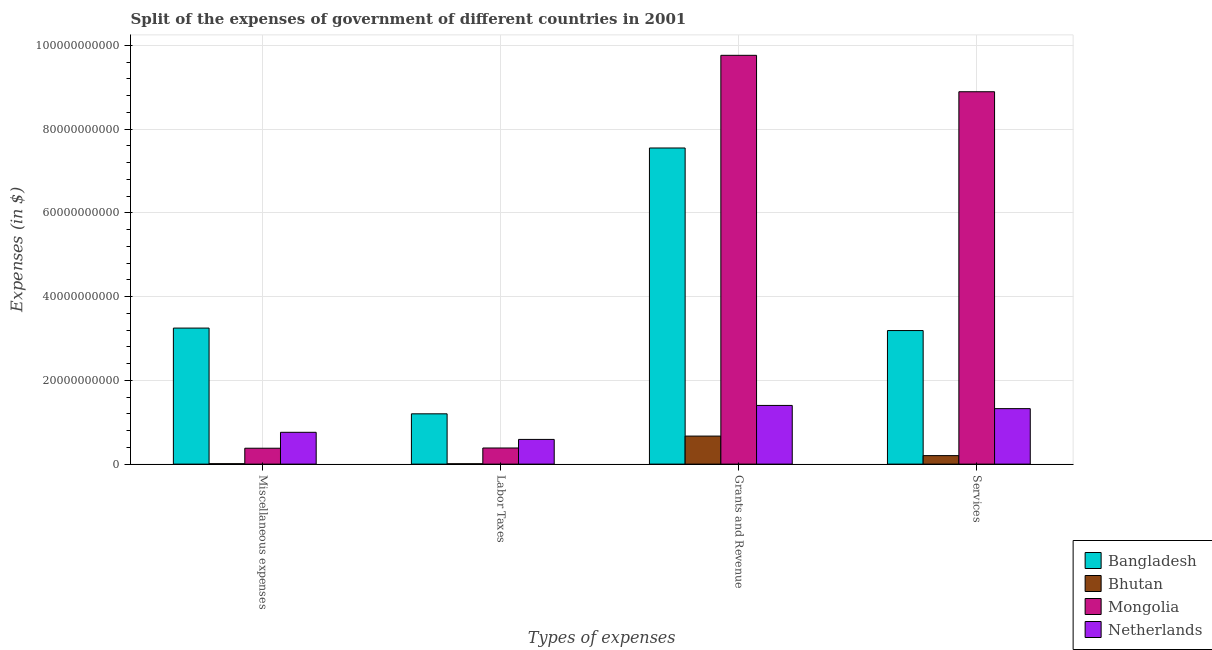Are the number of bars on each tick of the X-axis equal?
Offer a terse response. Yes. How many bars are there on the 4th tick from the left?
Offer a terse response. 4. How many bars are there on the 1st tick from the right?
Ensure brevity in your answer.  4. What is the label of the 4th group of bars from the left?
Provide a short and direct response. Services. What is the amount spent on miscellaneous expenses in Netherlands?
Provide a short and direct response. 7.60e+09. Across all countries, what is the maximum amount spent on services?
Your answer should be compact. 8.89e+1. Across all countries, what is the minimum amount spent on services?
Make the answer very short. 2.03e+09. In which country was the amount spent on services minimum?
Provide a succinct answer. Bhutan. What is the total amount spent on labor taxes in the graph?
Your answer should be compact. 2.18e+1. What is the difference between the amount spent on services in Netherlands and that in Mongolia?
Give a very brief answer. -7.57e+1. What is the difference between the amount spent on services in Netherlands and the amount spent on miscellaneous expenses in Mongolia?
Provide a succinct answer. 9.46e+09. What is the average amount spent on miscellaneous expenses per country?
Provide a succinct answer. 1.10e+1. What is the difference between the amount spent on labor taxes and amount spent on miscellaneous expenses in Mongolia?
Your response must be concise. 5.40e+07. In how many countries, is the amount spent on labor taxes greater than 48000000000 $?
Offer a terse response. 0. What is the ratio of the amount spent on labor taxes in Netherlands to that in Mongolia?
Keep it short and to the point. 1.53. Is the amount spent on miscellaneous expenses in Bangladesh less than that in Netherlands?
Make the answer very short. No. What is the difference between the highest and the second highest amount spent on labor taxes?
Ensure brevity in your answer.  6.11e+09. What is the difference between the highest and the lowest amount spent on grants and revenue?
Your answer should be compact. 9.09e+1. In how many countries, is the amount spent on miscellaneous expenses greater than the average amount spent on miscellaneous expenses taken over all countries?
Offer a very short reply. 1. What does the 3rd bar from the right in Grants and Revenue represents?
Your answer should be compact. Bhutan. Is it the case that in every country, the sum of the amount spent on miscellaneous expenses and amount spent on labor taxes is greater than the amount spent on grants and revenue?
Provide a succinct answer. No. How many countries are there in the graph?
Provide a succinct answer. 4. What is the difference between two consecutive major ticks on the Y-axis?
Provide a short and direct response. 2.00e+1. Where does the legend appear in the graph?
Offer a very short reply. Bottom right. What is the title of the graph?
Your answer should be very brief. Split of the expenses of government of different countries in 2001. What is the label or title of the X-axis?
Provide a succinct answer. Types of expenses. What is the label or title of the Y-axis?
Keep it short and to the point. Expenses (in $). What is the Expenses (in $) of Bangladesh in Miscellaneous expenses?
Give a very brief answer. 3.25e+1. What is the Expenses (in $) in Bhutan in Miscellaneous expenses?
Provide a short and direct response. 1.02e+08. What is the Expenses (in $) of Mongolia in Miscellaneous expenses?
Offer a very short reply. 3.80e+09. What is the Expenses (in $) in Netherlands in Miscellaneous expenses?
Give a very brief answer. 7.60e+09. What is the Expenses (in $) of Bangladesh in Labor Taxes?
Give a very brief answer. 1.20e+1. What is the Expenses (in $) of Bhutan in Labor Taxes?
Provide a succinct answer. 8.44e+07. What is the Expenses (in $) in Mongolia in Labor Taxes?
Offer a terse response. 3.85e+09. What is the Expenses (in $) in Netherlands in Labor Taxes?
Give a very brief answer. 5.90e+09. What is the Expenses (in $) of Bangladesh in Grants and Revenue?
Provide a short and direct response. 7.55e+1. What is the Expenses (in $) in Bhutan in Grants and Revenue?
Make the answer very short. 6.69e+09. What is the Expenses (in $) of Mongolia in Grants and Revenue?
Offer a terse response. 9.76e+1. What is the Expenses (in $) in Netherlands in Grants and Revenue?
Your answer should be compact. 1.40e+1. What is the Expenses (in $) in Bangladesh in Services?
Ensure brevity in your answer.  3.19e+1. What is the Expenses (in $) of Bhutan in Services?
Offer a very short reply. 2.03e+09. What is the Expenses (in $) of Mongolia in Services?
Your response must be concise. 8.89e+1. What is the Expenses (in $) of Netherlands in Services?
Keep it short and to the point. 1.33e+1. Across all Types of expenses, what is the maximum Expenses (in $) of Bangladesh?
Provide a succinct answer. 7.55e+1. Across all Types of expenses, what is the maximum Expenses (in $) of Bhutan?
Your response must be concise. 6.69e+09. Across all Types of expenses, what is the maximum Expenses (in $) of Mongolia?
Keep it short and to the point. 9.76e+1. Across all Types of expenses, what is the maximum Expenses (in $) of Netherlands?
Your response must be concise. 1.40e+1. Across all Types of expenses, what is the minimum Expenses (in $) of Bangladesh?
Your answer should be compact. 1.20e+1. Across all Types of expenses, what is the minimum Expenses (in $) in Bhutan?
Keep it short and to the point. 8.44e+07. Across all Types of expenses, what is the minimum Expenses (in $) in Mongolia?
Give a very brief answer. 3.80e+09. Across all Types of expenses, what is the minimum Expenses (in $) of Netherlands?
Offer a terse response. 5.90e+09. What is the total Expenses (in $) of Bangladesh in the graph?
Your response must be concise. 1.52e+11. What is the total Expenses (in $) of Bhutan in the graph?
Offer a very short reply. 8.91e+09. What is the total Expenses (in $) in Mongolia in the graph?
Offer a terse response. 1.94e+11. What is the total Expenses (in $) in Netherlands in the graph?
Offer a terse response. 4.08e+1. What is the difference between the Expenses (in $) of Bangladesh in Miscellaneous expenses and that in Labor Taxes?
Your response must be concise. 2.05e+1. What is the difference between the Expenses (in $) of Bhutan in Miscellaneous expenses and that in Labor Taxes?
Ensure brevity in your answer.  1.74e+07. What is the difference between the Expenses (in $) in Mongolia in Miscellaneous expenses and that in Labor Taxes?
Ensure brevity in your answer.  -5.40e+07. What is the difference between the Expenses (in $) in Netherlands in Miscellaneous expenses and that in Labor Taxes?
Offer a very short reply. 1.70e+09. What is the difference between the Expenses (in $) in Bangladesh in Miscellaneous expenses and that in Grants and Revenue?
Offer a very short reply. -4.30e+1. What is the difference between the Expenses (in $) in Bhutan in Miscellaneous expenses and that in Grants and Revenue?
Offer a terse response. -6.59e+09. What is the difference between the Expenses (in $) in Mongolia in Miscellaneous expenses and that in Grants and Revenue?
Keep it short and to the point. -9.38e+1. What is the difference between the Expenses (in $) in Netherlands in Miscellaneous expenses and that in Grants and Revenue?
Your response must be concise. -6.42e+09. What is the difference between the Expenses (in $) in Bangladesh in Miscellaneous expenses and that in Services?
Give a very brief answer. 5.89e+08. What is the difference between the Expenses (in $) in Bhutan in Miscellaneous expenses and that in Services?
Ensure brevity in your answer.  -1.93e+09. What is the difference between the Expenses (in $) in Mongolia in Miscellaneous expenses and that in Services?
Offer a very short reply. -8.51e+1. What is the difference between the Expenses (in $) in Netherlands in Miscellaneous expenses and that in Services?
Keep it short and to the point. -5.65e+09. What is the difference between the Expenses (in $) of Bangladesh in Labor Taxes and that in Grants and Revenue?
Your answer should be compact. -6.35e+1. What is the difference between the Expenses (in $) of Bhutan in Labor Taxes and that in Grants and Revenue?
Your answer should be very brief. -6.61e+09. What is the difference between the Expenses (in $) in Mongolia in Labor Taxes and that in Grants and Revenue?
Make the answer very short. -9.38e+1. What is the difference between the Expenses (in $) in Netherlands in Labor Taxes and that in Grants and Revenue?
Offer a terse response. -8.12e+09. What is the difference between the Expenses (in $) of Bangladesh in Labor Taxes and that in Services?
Offer a terse response. -1.99e+1. What is the difference between the Expenses (in $) of Bhutan in Labor Taxes and that in Services?
Make the answer very short. -1.94e+09. What is the difference between the Expenses (in $) of Mongolia in Labor Taxes and that in Services?
Your answer should be compact. -8.51e+1. What is the difference between the Expenses (in $) in Netherlands in Labor Taxes and that in Services?
Keep it short and to the point. -7.35e+09. What is the difference between the Expenses (in $) of Bangladesh in Grants and Revenue and that in Services?
Offer a very short reply. 4.36e+1. What is the difference between the Expenses (in $) in Bhutan in Grants and Revenue and that in Services?
Your answer should be very brief. 4.67e+09. What is the difference between the Expenses (in $) in Mongolia in Grants and Revenue and that in Services?
Provide a succinct answer. 8.70e+09. What is the difference between the Expenses (in $) in Netherlands in Grants and Revenue and that in Services?
Your answer should be very brief. 7.64e+08. What is the difference between the Expenses (in $) of Bangladesh in Miscellaneous expenses and the Expenses (in $) of Bhutan in Labor Taxes?
Your response must be concise. 3.24e+1. What is the difference between the Expenses (in $) of Bangladesh in Miscellaneous expenses and the Expenses (in $) of Mongolia in Labor Taxes?
Ensure brevity in your answer.  2.86e+1. What is the difference between the Expenses (in $) of Bangladesh in Miscellaneous expenses and the Expenses (in $) of Netherlands in Labor Taxes?
Offer a terse response. 2.66e+1. What is the difference between the Expenses (in $) in Bhutan in Miscellaneous expenses and the Expenses (in $) in Mongolia in Labor Taxes?
Offer a terse response. -3.75e+09. What is the difference between the Expenses (in $) of Bhutan in Miscellaneous expenses and the Expenses (in $) of Netherlands in Labor Taxes?
Ensure brevity in your answer.  -5.80e+09. What is the difference between the Expenses (in $) in Mongolia in Miscellaneous expenses and the Expenses (in $) in Netherlands in Labor Taxes?
Your answer should be compact. -2.10e+09. What is the difference between the Expenses (in $) in Bangladesh in Miscellaneous expenses and the Expenses (in $) in Bhutan in Grants and Revenue?
Offer a very short reply. 2.58e+1. What is the difference between the Expenses (in $) of Bangladesh in Miscellaneous expenses and the Expenses (in $) of Mongolia in Grants and Revenue?
Keep it short and to the point. -6.51e+1. What is the difference between the Expenses (in $) in Bangladesh in Miscellaneous expenses and the Expenses (in $) in Netherlands in Grants and Revenue?
Keep it short and to the point. 1.85e+1. What is the difference between the Expenses (in $) in Bhutan in Miscellaneous expenses and the Expenses (in $) in Mongolia in Grants and Revenue?
Your answer should be compact. -9.75e+1. What is the difference between the Expenses (in $) of Bhutan in Miscellaneous expenses and the Expenses (in $) of Netherlands in Grants and Revenue?
Keep it short and to the point. -1.39e+1. What is the difference between the Expenses (in $) in Mongolia in Miscellaneous expenses and the Expenses (in $) in Netherlands in Grants and Revenue?
Ensure brevity in your answer.  -1.02e+1. What is the difference between the Expenses (in $) of Bangladesh in Miscellaneous expenses and the Expenses (in $) of Bhutan in Services?
Provide a short and direct response. 3.05e+1. What is the difference between the Expenses (in $) in Bangladesh in Miscellaneous expenses and the Expenses (in $) in Mongolia in Services?
Your answer should be very brief. -5.64e+1. What is the difference between the Expenses (in $) in Bangladesh in Miscellaneous expenses and the Expenses (in $) in Netherlands in Services?
Provide a short and direct response. 1.92e+1. What is the difference between the Expenses (in $) in Bhutan in Miscellaneous expenses and the Expenses (in $) in Mongolia in Services?
Ensure brevity in your answer.  -8.88e+1. What is the difference between the Expenses (in $) of Bhutan in Miscellaneous expenses and the Expenses (in $) of Netherlands in Services?
Provide a short and direct response. -1.31e+1. What is the difference between the Expenses (in $) in Mongolia in Miscellaneous expenses and the Expenses (in $) in Netherlands in Services?
Ensure brevity in your answer.  -9.46e+09. What is the difference between the Expenses (in $) of Bangladesh in Labor Taxes and the Expenses (in $) of Bhutan in Grants and Revenue?
Give a very brief answer. 5.32e+09. What is the difference between the Expenses (in $) of Bangladesh in Labor Taxes and the Expenses (in $) of Mongolia in Grants and Revenue?
Offer a very short reply. -8.56e+1. What is the difference between the Expenses (in $) of Bangladesh in Labor Taxes and the Expenses (in $) of Netherlands in Grants and Revenue?
Offer a very short reply. -2.00e+09. What is the difference between the Expenses (in $) of Bhutan in Labor Taxes and the Expenses (in $) of Mongolia in Grants and Revenue?
Offer a very short reply. -9.75e+1. What is the difference between the Expenses (in $) in Bhutan in Labor Taxes and the Expenses (in $) in Netherlands in Grants and Revenue?
Keep it short and to the point. -1.39e+1. What is the difference between the Expenses (in $) in Mongolia in Labor Taxes and the Expenses (in $) in Netherlands in Grants and Revenue?
Provide a succinct answer. -1.02e+1. What is the difference between the Expenses (in $) in Bangladesh in Labor Taxes and the Expenses (in $) in Bhutan in Services?
Offer a terse response. 9.98e+09. What is the difference between the Expenses (in $) of Bangladesh in Labor Taxes and the Expenses (in $) of Mongolia in Services?
Offer a terse response. -7.69e+1. What is the difference between the Expenses (in $) in Bangladesh in Labor Taxes and the Expenses (in $) in Netherlands in Services?
Your answer should be very brief. -1.24e+09. What is the difference between the Expenses (in $) in Bhutan in Labor Taxes and the Expenses (in $) in Mongolia in Services?
Make the answer very short. -8.88e+1. What is the difference between the Expenses (in $) of Bhutan in Labor Taxes and the Expenses (in $) of Netherlands in Services?
Provide a succinct answer. -1.32e+1. What is the difference between the Expenses (in $) in Mongolia in Labor Taxes and the Expenses (in $) in Netherlands in Services?
Give a very brief answer. -9.40e+09. What is the difference between the Expenses (in $) of Bangladesh in Grants and Revenue and the Expenses (in $) of Bhutan in Services?
Ensure brevity in your answer.  7.35e+1. What is the difference between the Expenses (in $) of Bangladesh in Grants and Revenue and the Expenses (in $) of Mongolia in Services?
Offer a terse response. -1.34e+1. What is the difference between the Expenses (in $) in Bangladesh in Grants and Revenue and the Expenses (in $) in Netherlands in Services?
Keep it short and to the point. 6.22e+1. What is the difference between the Expenses (in $) of Bhutan in Grants and Revenue and the Expenses (in $) of Mongolia in Services?
Make the answer very short. -8.22e+1. What is the difference between the Expenses (in $) in Bhutan in Grants and Revenue and the Expenses (in $) in Netherlands in Services?
Provide a succinct answer. -6.56e+09. What is the difference between the Expenses (in $) in Mongolia in Grants and Revenue and the Expenses (in $) in Netherlands in Services?
Your response must be concise. 8.44e+1. What is the average Expenses (in $) in Bangladesh per Types of expenses?
Your answer should be compact. 3.80e+1. What is the average Expenses (in $) in Bhutan per Types of expenses?
Ensure brevity in your answer.  2.23e+09. What is the average Expenses (in $) of Mongolia per Types of expenses?
Keep it short and to the point. 4.86e+1. What is the average Expenses (in $) in Netherlands per Types of expenses?
Offer a very short reply. 1.02e+1. What is the difference between the Expenses (in $) in Bangladesh and Expenses (in $) in Bhutan in Miscellaneous expenses?
Your answer should be compact. 3.24e+1. What is the difference between the Expenses (in $) in Bangladesh and Expenses (in $) in Mongolia in Miscellaneous expenses?
Offer a terse response. 2.87e+1. What is the difference between the Expenses (in $) of Bangladesh and Expenses (in $) of Netherlands in Miscellaneous expenses?
Keep it short and to the point. 2.49e+1. What is the difference between the Expenses (in $) of Bhutan and Expenses (in $) of Mongolia in Miscellaneous expenses?
Offer a terse response. -3.69e+09. What is the difference between the Expenses (in $) of Bhutan and Expenses (in $) of Netherlands in Miscellaneous expenses?
Provide a succinct answer. -7.50e+09. What is the difference between the Expenses (in $) in Mongolia and Expenses (in $) in Netherlands in Miscellaneous expenses?
Your response must be concise. -3.80e+09. What is the difference between the Expenses (in $) in Bangladesh and Expenses (in $) in Bhutan in Labor Taxes?
Keep it short and to the point. 1.19e+1. What is the difference between the Expenses (in $) of Bangladesh and Expenses (in $) of Mongolia in Labor Taxes?
Your answer should be compact. 8.16e+09. What is the difference between the Expenses (in $) in Bangladesh and Expenses (in $) in Netherlands in Labor Taxes?
Your answer should be compact. 6.11e+09. What is the difference between the Expenses (in $) in Bhutan and Expenses (in $) in Mongolia in Labor Taxes?
Provide a succinct answer. -3.77e+09. What is the difference between the Expenses (in $) of Bhutan and Expenses (in $) of Netherlands in Labor Taxes?
Your answer should be very brief. -5.81e+09. What is the difference between the Expenses (in $) of Mongolia and Expenses (in $) of Netherlands in Labor Taxes?
Your answer should be compact. -2.05e+09. What is the difference between the Expenses (in $) of Bangladesh and Expenses (in $) of Bhutan in Grants and Revenue?
Offer a very short reply. 6.88e+1. What is the difference between the Expenses (in $) in Bangladesh and Expenses (in $) in Mongolia in Grants and Revenue?
Make the answer very short. -2.21e+1. What is the difference between the Expenses (in $) of Bangladesh and Expenses (in $) of Netherlands in Grants and Revenue?
Your response must be concise. 6.15e+1. What is the difference between the Expenses (in $) of Bhutan and Expenses (in $) of Mongolia in Grants and Revenue?
Provide a succinct answer. -9.09e+1. What is the difference between the Expenses (in $) in Bhutan and Expenses (in $) in Netherlands in Grants and Revenue?
Offer a terse response. -7.32e+09. What is the difference between the Expenses (in $) of Mongolia and Expenses (in $) of Netherlands in Grants and Revenue?
Give a very brief answer. 8.36e+1. What is the difference between the Expenses (in $) of Bangladesh and Expenses (in $) of Bhutan in Services?
Offer a very short reply. 2.99e+1. What is the difference between the Expenses (in $) of Bangladesh and Expenses (in $) of Mongolia in Services?
Offer a very short reply. -5.70e+1. What is the difference between the Expenses (in $) in Bangladesh and Expenses (in $) in Netherlands in Services?
Provide a succinct answer. 1.86e+1. What is the difference between the Expenses (in $) of Bhutan and Expenses (in $) of Mongolia in Services?
Offer a very short reply. -8.69e+1. What is the difference between the Expenses (in $) of Bhutan and Expenses (in $) of Netherlands in Services?
Give a very brief answer. -1.12e+1. What is the difference between the Expenses (in $) of Mongolia and Expenses (in $) of Netherlands in Services?
Make the answer very short. 7.57e+1. What is the ratio of the Expenses (in $) of Bangladesh in Miscellaneous expenses to that in Labor Taxes?
Offer a terse response. 2.7. What is the ratio of the Expenses (in $) in Bhutan in Miscellaneous expenses to that in Labor Taxes?
Offer a very short reply. 1.21. What is the ratio of the Expenses (in $) in Netherlands in Miscellaneous expenses to that in Labor Taxes?
Make the answer very short. 1.29. What is the ratio of the Expenses (in $) in Bangladesh in Miscellaneous expenses to that in Grants and Revenue?
Provide a succinct answer. 0.43. What is the ratio of the Expenses (in $) in Bhutan in Miscellaneous expenses to that in Grants and Revenue?
Your response must be concise. 0.02. What is the ratio of the Expenses (in $) in Mongolia in Miscellaneous expenses to that in Grants and Revenue?
Your answer should be compact. 0.04. What is the ratio of the Expenses (in $) of Netherlands in Miscellaneous expenses to that in Grants and Revenue?
Keep it short and to the point. 0.54. What is the ratio of the Expenses (in $) of Bangladesh in Miscellaneous expenses to that in Services?
Your answer should be very brief. 1.02. What is the ratio of the Expenses (in $) of Bhutan in Miscellaneous expenses to that in Services?
Offer a terse response. 0.05. What is the ratio of the Expenses (in $) of Mongolia in Miscellaneous expenses to that in Services?
Provide a short and direct response. 0.04. What is the ratio of the Expenses (in $) of Netherlands in Miscellaneous expenses to that in Services?
Offer a terse response. 0.57. What is the ratio of the Expenses (in $) of Bangladesh in Labor Taxes to that in Grants and Revenue?
Your response must be concise. 0.16. What is the ratio of the Expenses (in $) in Bhutan in Labor Taxes to that in Grants and Revenue?
Keep it short and to the point. 0.01. What is the ratio of the Expenses (in $) of Mongolia in Labor Taxes to that in Grants and Revenue?
Ensure brevity in your answer.  0.04. What is the ratio of the Expenses (in $) of Netherlands in Labor Taxes to that in Grants and Revenue?
Offer a very short reply. 0.42. What is the ratio of the Expenses (in $) in Bangladesh in Labor Taxes to that in Services?
Offer a terse response. 0.38. What is the ratio of the Expenses (in $) in Bhutan in Labor Taxes to that in Services?
Provide a short and direct response. 0.04. What is the ratio of the Expenses (in $) of Mongolia in Labor Taxes to that in Services?
Ensure brevity in your answer.  0.04. What is the ratio of the Expenses (in $) in Netherlands in Labor Taxes to that in Services?
Offer a very short reply. 0.45. What is the ratio of the Expenses (in $) in Bangladesh in Grants and Revenue to that in Services?
Keep it short and to the point. 2.37. What is the ratio of the Expenses (in $) of Bhutan in Grants and Revenue to that in Services?
Offer a terse response. 3.3. What is the ratio of the Expenses (in $) in Mongolia in Grants and Revenue to that in Services?
Your answer should be compact. 1.1. What is the ratio of the Expenses (in $) of Netherlands in Grants and Revenue to that in Services?
Provide a succinct answer. 1.06. What is the difference between the highest and the second highest Expenses (in $) in Bangladesh?
Offer a terse response. 4.30e+1. What is the difference between the highest and the second highest Expenses (in $) of Bhutan?
Keep it short and to the point. 4.67e+09. What is the difference between the highest and the second highest Expenses (in $) in Mongolia?
Your answer should be compact. 8.70e+09. What is the difference between the highest and the second highest Expenses (in $) of Netherlands?
Give a very brief answer. 7.64e+08. What is the difference between the highest and the lowest Expenses (in $) of Bangladesh?
Give a very brief answer. 6.35e+1. What is the difference between the highest and the lowest Expenses (in $) of Bhutan?
Your response must be concise. 6.61e+09. What is the difference between the highest and the lowest Expenses (in $) of Mongolia?
Keep it short and to the point. 9.38e+1. What is the difference between the highest and the lowest Expenses (in $) of Netherlands?
Offer a terse response. 8.12e+09. 